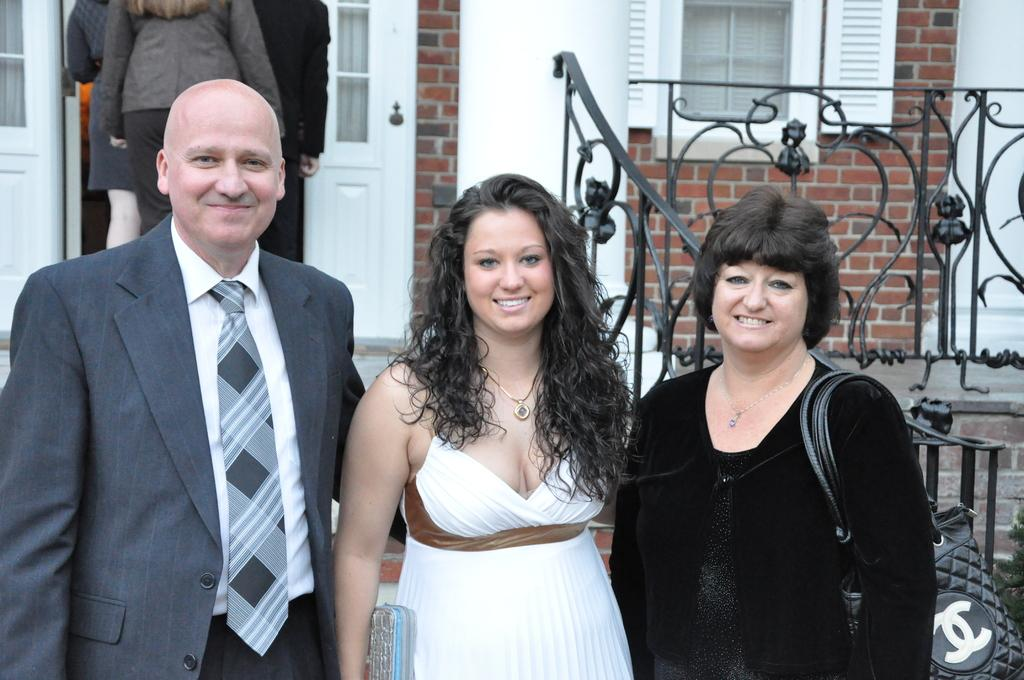How many people are present in the image? There are three persons standing in the image. Can you describe the attire of one of the persons? One of the persons is wearing a bag. What can be seen in the background of the image? There is a fence, a wall, windows, other persons, and a door in the background of the image. What grade is the expert teaching in the image? There is no expert or teaching activity present in the image. What type of plants can be seen growing near the fence in the image? There is no mention of plants in the image; the focus is on the fence, wall, windows, other persons, and door in the background. 